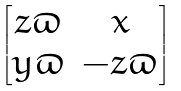Convert formula to latex. <formula><loc_0><loc_0><loc_500><loc_500>\begin{bmatrix} z \varpi & x \\ y \varpi & - z \varpi \end{bmatrix}</formula> 